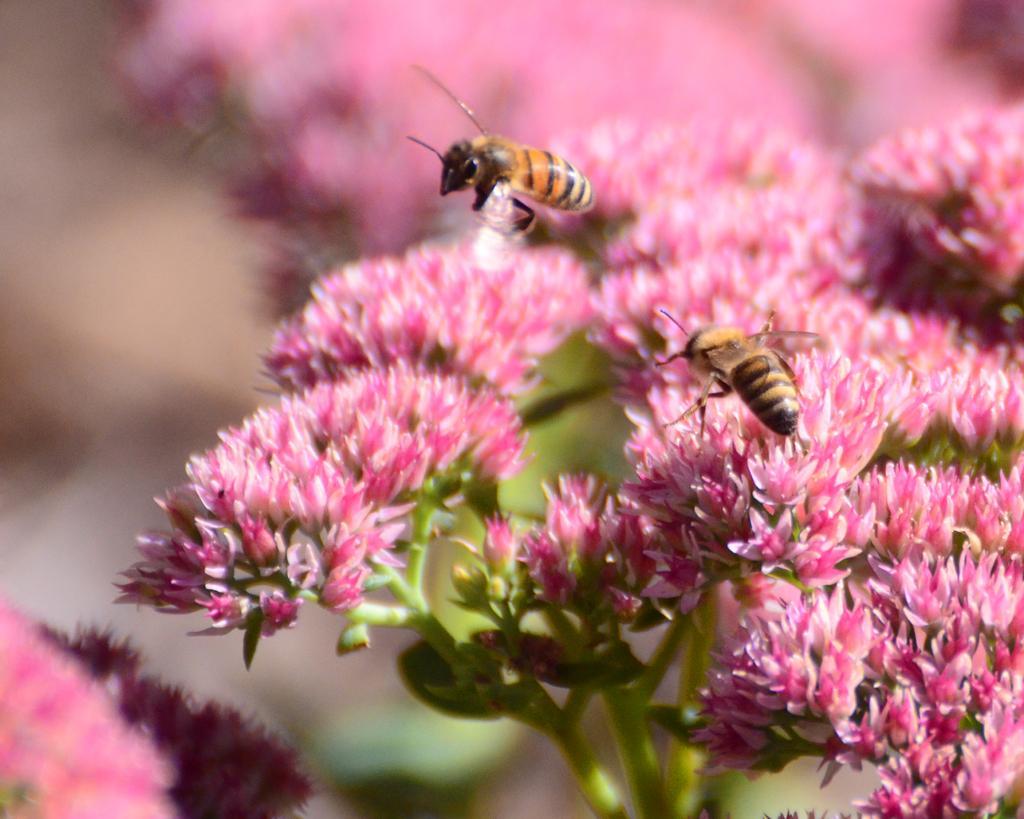Could you give a brief overview of what you see in this image? In this image we can see flowers and there is an insect on the flower and other insect is in the air. In the background the image is blur but we can see flowers. 